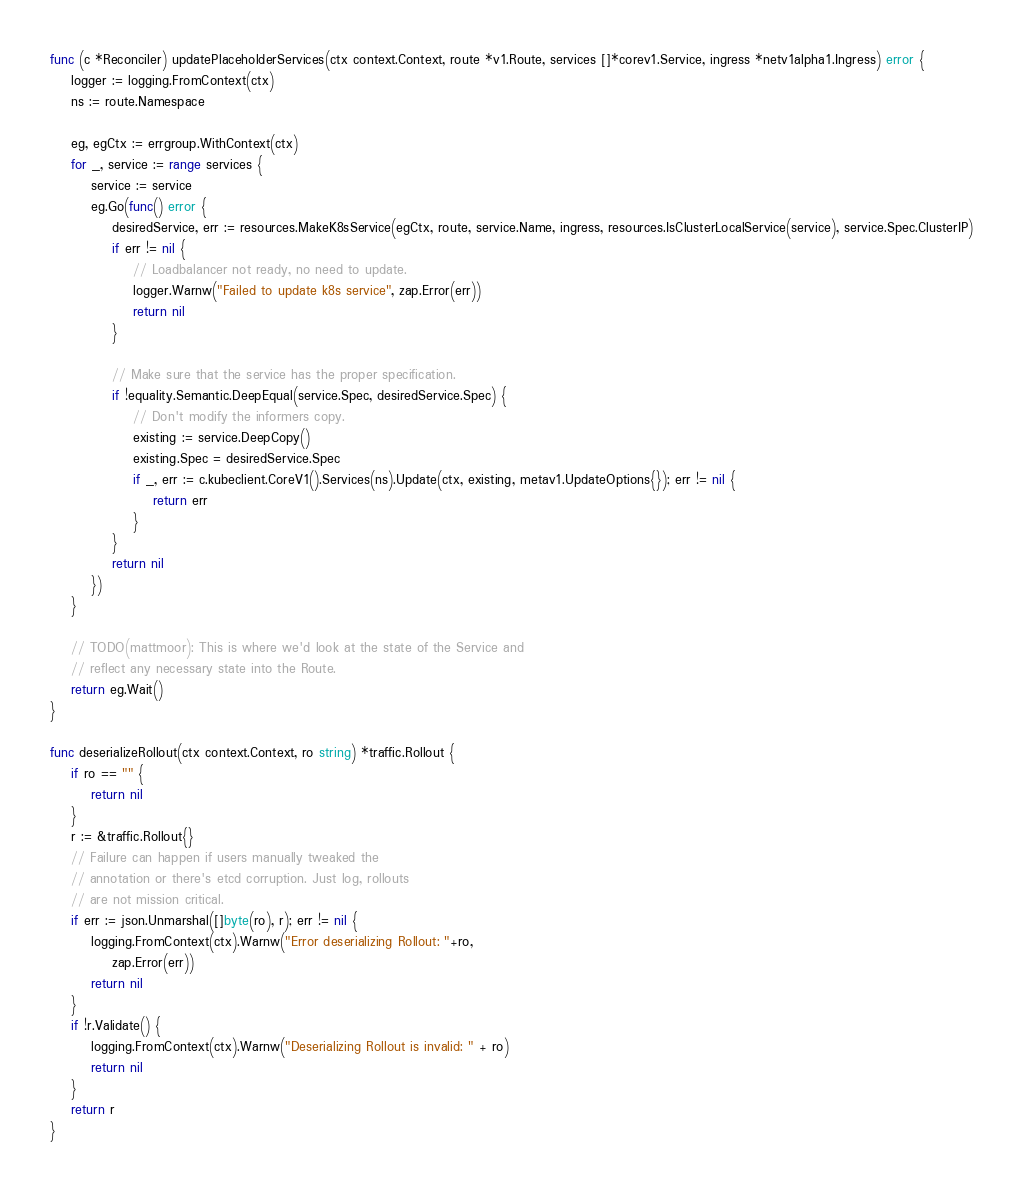<code> <loc_0><loc_0><loc_500><loc_500><_Go_>
func (c *Reconciler) updatePlaceholderServices(ctx context.Context, route *v1.Route, services []*corev1.Service, ingress *netv1alpha1.Ingress) error {
	logger := logging.FromContext(ctx)
	ns := route.Namespace

	eg, egCtx := errgroup.WithContext(ctx)
	for _, service := range services {
		service := service
		eg.Go(func() error {
			desiredService, err := resources.MakeK8sService(egCtx, route, service.Name, ingress, resources.IsClusterLocalService(service), service.Spec.ClusterIP)
			if err != nil {
				// Loadbalancer not ready, no need to update.
				logger.Warnw("Failed to update k8s service", zap.Error(err))
				return nil
			}

			// Make sure that the service has the proper specification.
			if !equality.Semantic.DeepEqual(service.Spec, desiredService.Spec) {
				// Don't modify the informers copy.
				existing := service.DeepCopy()
				existing.Spec = desiredService.Spec
				if _, err := c.kubeclient.CoreV1().Services(ns).Update(ctx, existing, metav1.UpdateOptions{}); err != nil {
					return err
				}
			}
			return nil
		})
	}

	// TODO(mattmoor): This is where we'd look at the state of the Service and
	// reflect any necessary state into the Route.
	return eg.Wait()
}

func deserializeRollout(ctx context.Context, ro string) *traffic.Rollout {
	if ro == "" {
		return nil
	}
	r := &traffic.Rollout{}
	// Failure can happen if users manually tweaked the
	// annotation or there's etcd corruption. Just log, rollouts
	// are not mission critical.
	if err := json.Unmarshal([]byte(ro), r); err != nil {
		logging.FromContext(ctx).Warnw("Error deserializing Rollout: "+ro,
			zap.Error(err))
		return nil
	}
	if !r.Validate() {
		logging.FromContext(ctx).Warnw("Deserializing Rollout is invalid: " + ro)
		return nil
	}
	return r
}
</code> 